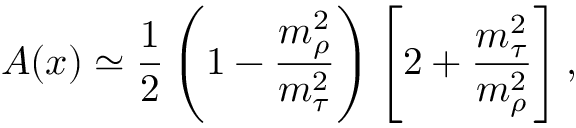Convert formula to latex. <formula><loc_0><loc_0><loc_500><loc_500>A ( x ) \simeq { \frac { 1 } { 2 } } \left ( 1 - { \frac { m _ { \rho } ^ { 2 } } { m _ { \tau } ^ { 2 } } } \right ) \left [ 2 + { \frac { m _ { \tau } ^ { 2 } } { m _ { \rho } ^ { 2 } } } \right ] ,</formula> 